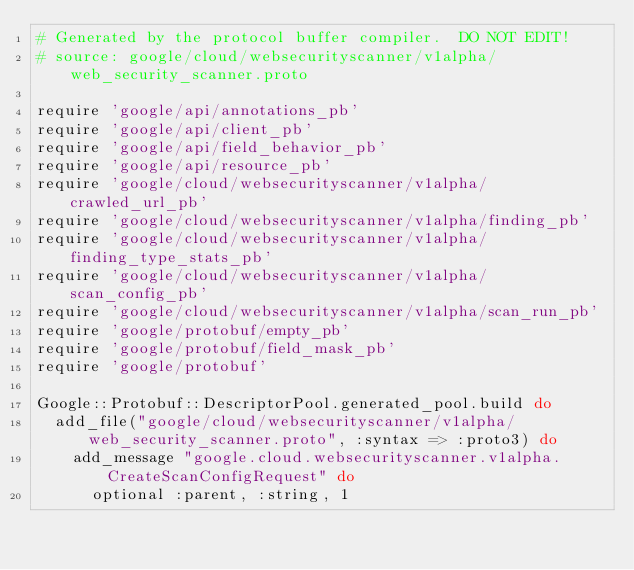<code> <loc_0><loc_0><loc_500><loc_500><_Ruby_># Generated by the protocol buffer compiler.  DO NOT EDIT!
# source: google/cloud/websecurityscanner/v1alpha/web_security_scanner.proto

require 'google/api/annotations_pb'
require 'google/api/client_pb'
require 'google/api/field_behavior_pb'
require 'google/api/resource_pb'
require 'google/cloud/websecurityscanner/v1alpha/crawled_url_pb'
require 'google/cloud/websecurityscanner/v1alpha/finding_pb'
require 'google/cloud/websecurityscanner/v1alpha/finding_type_stats_pb'
require 'google/cloud/websecurityscanner/v1alpha/scan_config_pb'
require 'google/cloud/websecurityscanner/v1alpha/scan_run_pb'
require 'google/protobuf/empty_pb'
require 'google/protobuf/field_mask_pb'
require 'google/protobuf'

Google::Protobuf::DescriptorPool.generated_pool.build do
  add_file("google/cloud/websecurityscanner/v1alpha/web_security_scanner.proto", :syntax => :proto3) do
    add_message "google.cloud.websecurityscanner.v1alpha.CreateScanConfigRequest" do
      optional :parent, :string, 1</code> 